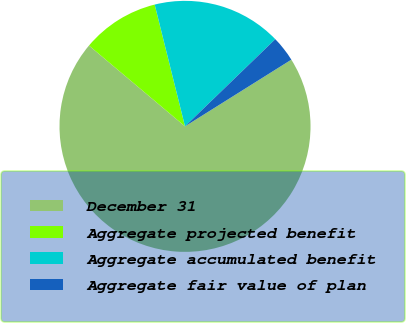Convert chart to OTSL. <chart><loc_0><loc_0><loc_500><loc_500><pie_chart><fcel>December 31<fcel>Aggregate projected benefit<fcel>Aggregate accumulated benefit<fcel>Aggregate fair value of plan<nl><fcel>70.05%<fcel>9.98%<fcel>16.66%<fcel>3.31%<nl></chart> 